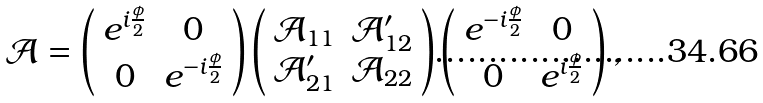<formula> <loc_0><loc_0><loc_500><loc_500>\mathcal { A } = \left ( \begin{array} { c c } e ^ { i \frac { \phi } { 2 } } & 0 \\ 0 & e ^ { - i \frac { \phi } { 2 } } \end{array} \right ) \left ( \begin{array} { c c } \mathcal { A } _ { 1 1 } & \mathcal { A } ^ { \prime } _ { 1 2 } \\ \mathcal { A } ^ { \prime } _ { 2 1 } & \mathcal { A } _ { 2 2 } \end{array} \right ) \left ( \begin{array} { c c } e ^ { - i \frac { \phi } { 2 } } & 0 \\ 0 & e ^ { i \frac { \phi } { 2 } } \end{array} \right ) ,</formula> 